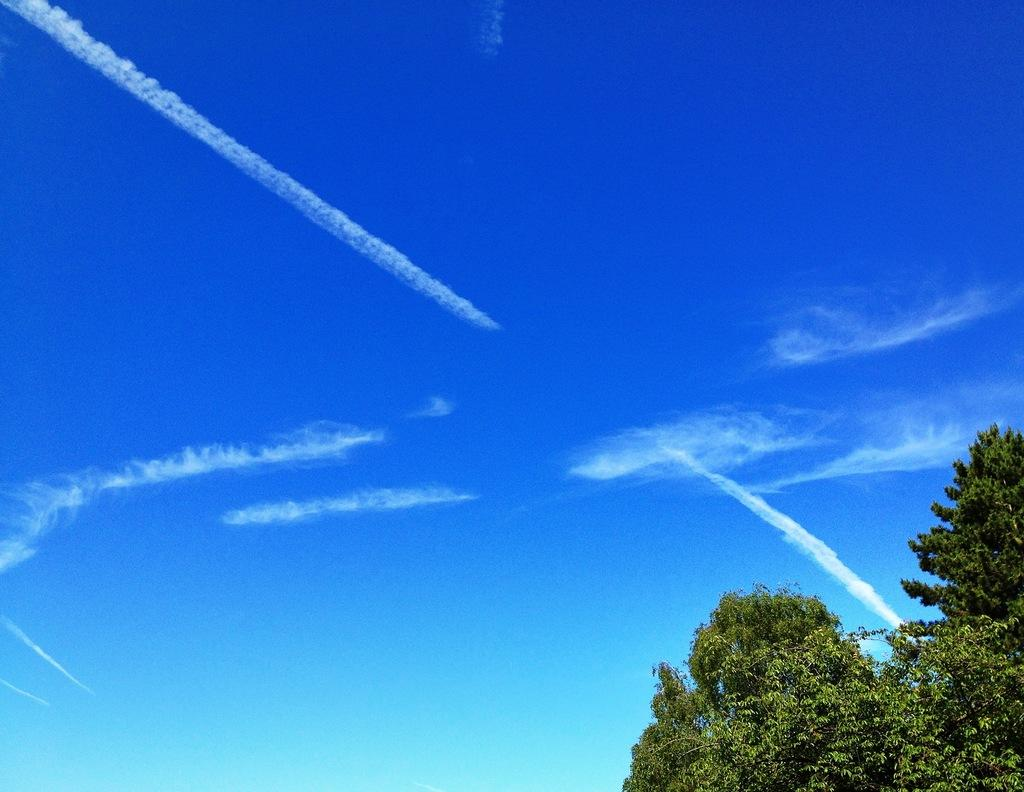What can be seen at the top of the image? The sky is visible in the image. Where is the tree located in the image? There is a tree in the bottom right corner of the image. What type of kitty is learning to cook beef in the image? There is no kitty or beef present in the image. 